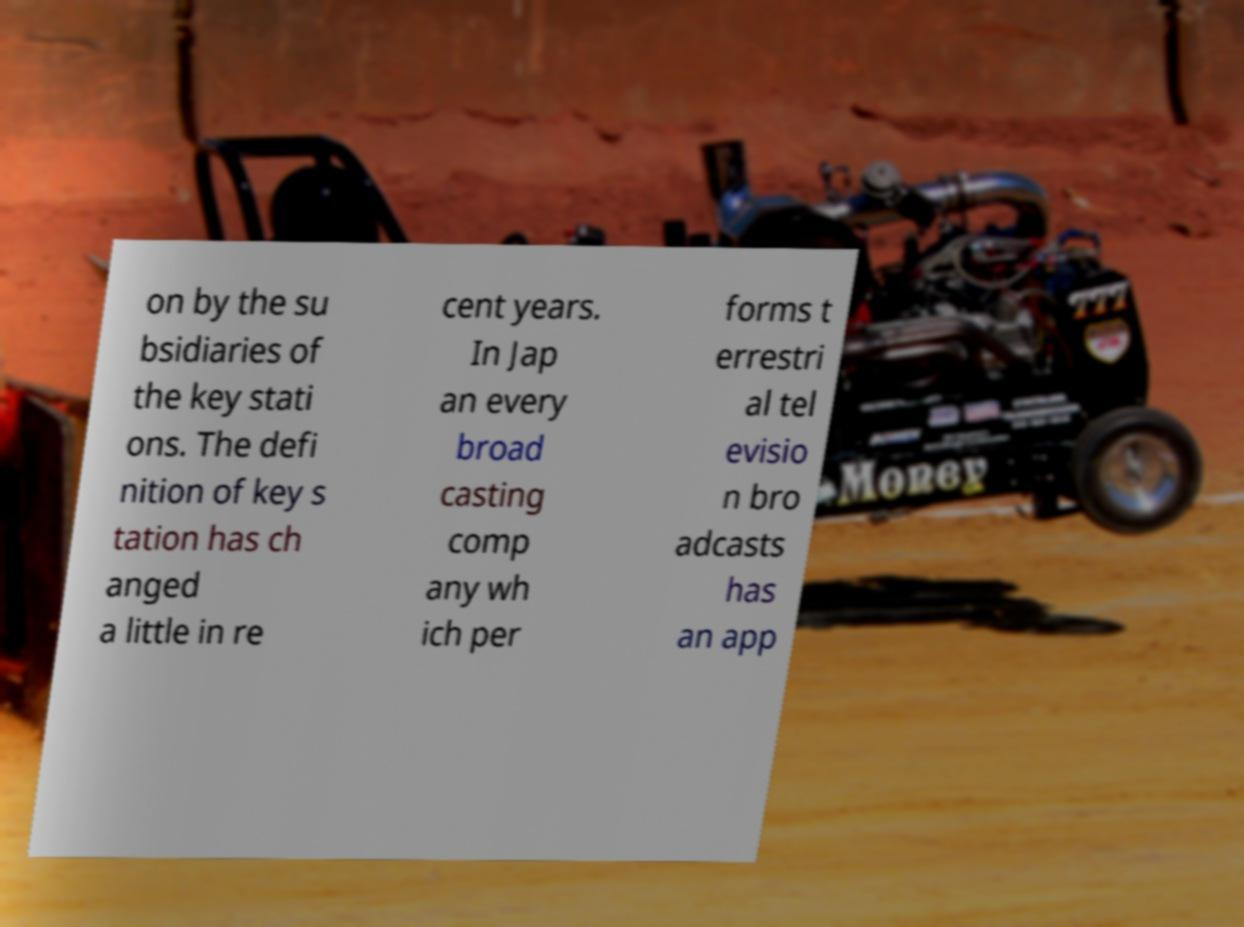Please identify and transcribe the text found in this image. on by the su bsidiaries of the key stati ons. The defi nition of key s tation has ch anged a little in re cent years. In Jap an every broad casting comp any wh ich per forms t errestri al tel evisio n bro adcasts has an app 